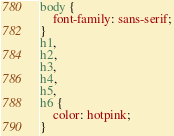Convert code to text. <code><loc_0><loc_0><loc_500><loc_500><_CSS_>body {
    font-family: sans-serif;
} 
h1, 
h2, 
h3, 
h4, 
h5, 
h6 {
    color: hotpink;
}

</code> 